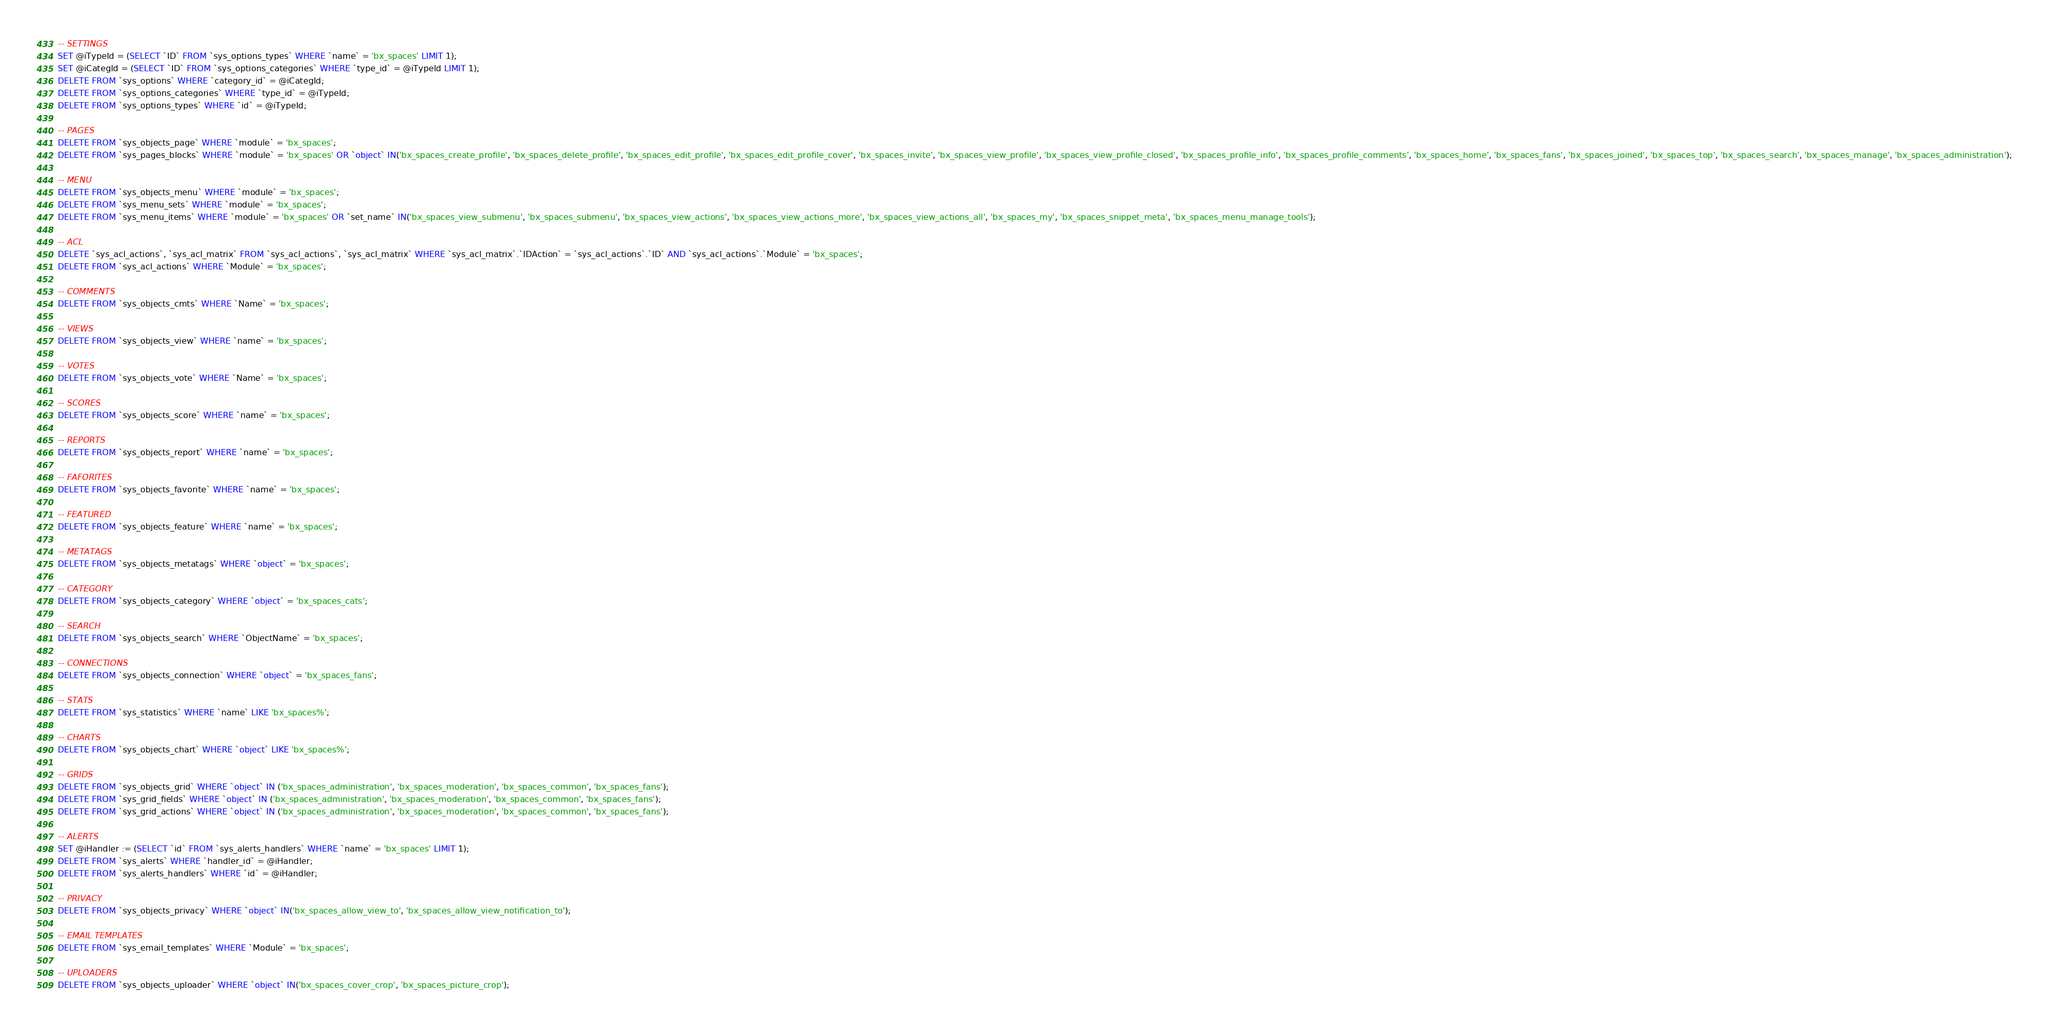<code> <loc_0><loc_0><loc_500><loc_500><_SQL_>
-- SETTINGS
SET @iTypeId = (SELECT `ID` FROM `sys_options_types` WHERE `name` = 'bx_spaces' LIMIT 1);
SET @iCategId = (SELECT `ID` FROM `sys_options_categories` WHERE `type_id` = @iTypeId LIMIT 1);
DELETE FROM `sys_options` WHERE `category_id` = @iCategId;
DELETE FROM `sys_options_categories` WHERE `type_id` = @iTypeId;
DELETE FROM `sys_options_types` WHERE `id` = @iTypeId;

-- PAGES
DELETE FROM `sys_objects_page` WHERE `module` = 'bx_spaces';
DELETE FROM `sys_pages_blocks` WHERE `module` = 'bx_spaces' OR `object` IN('bx_spaces_create_profile', 'bx_spaces_delete_profile', 'bx_spaces_edit_profile', 'bx_spaces_edit_profile_cover', 'bx_spaces_invite', 'bx_spaces_view_profile', 'bx_spaces_view_profile_closed', 'bx_spaces_profile_info', 'bx_spaces_profile_comments', 'bx_spaces_home', 'bx_spaces_fans', 'bx_spaces_joined', 'bx_spaces_top', 'bx_spaces_search', 'bx_spaces_manage', 'bx_spaces_administration');

-- MENU
DELETE FROM `sys_objects_menu` WHERE `module` = 'bx_spaces';
DELETE FROM `sys_menu_sets` WHERE `module` = 'bx_spaces';
DELETE FROM `sys_menu_items` WHERE `module` = 'bx_spaces' OR `set_name` IN('bx_spaces_view_submenu', 'bx_spaces_submenu', 'bx_spaces_view_actions', 'bx_spaces_view_actions_more', 'bx_spaces_view_actions_all', 'bx_spaces_my', 'bx_spaces_snippet_meta', 'bx_spaces_menu_manage_tools');

-- ACL
DELETE `sys_acl_actions`, `sys_acl_matrix` FROM `sys_acl_actions`, `sys_acl_matrix` WHERE `sys_acl_matrix`.`IDAction` = `sys_acl_actions`.`ID` AND `sys_acl_actions`.`Module` = 'bx_spaces';
DELETE FROM `sys_acl_actions` WHERE `Module` = 'bx_spaces';

-- COMMENTS
DELETE FROM `sys_objects_cmts` WHERE `Name` = 'bx_spaces';

-- VIEWS
DELETE FROM `sys_objects_view` WHERE `name` = 'bx_spaces';

-- VOTES
DELETE FROM `sys_objects_vote` WHERE `Name` = 'bx_spaces';

-- SCORES
DELETE FROM `sys_objects_score` WHERE `name` = 'bx_spaces';

-- REPORTS
DELETE FROM `sys_objects_report` WHERE `name` = 'bx_spaces';

-- FAFORITES
DELETE FROM `sys_objects_favorite` WHERE `name` = 'bx_spaces';

-- FEATURED
DELETE FROM `sys_objects_feature` WHERE `name` = 'bx_spaces';

-- METATAGS
DELETE FROM `sys_objects_metatags` WHERE `object` = 'bx_spaces';

-- CATEGORY
DELETE FROM `sys_objects_category` WHERE `object` = 'bx_spaces_cats';

-- SEARCH
DELETE FROM `sys_objects_search` WHERE `ObjectName` = 'bx_spaces';

-- CONNECTIONS
DELETE FROM `sys_objects_connection` WHERE `object` = 'bx_spaces_fans';

-- STATS
DELETE FROM `sys_statistics` WHERE `name` LIKE 'bx_spaces%';

-- CHARTS
DELETE FROM `sys_objects_chart` WHERE `object` LIKE 'bx_spaces%';

-- GRIDS
DELETE FROM `sys_objects_grid` WHERE `object` IN ('bx_spaces_administration', 'bx_spaces_moderation', 'bx_spaces_common', 'bx_spaces_fans');
DELETE FROM `sys_grid_fields` WHERE `object` IN ('bx_spaces_administration', 'bx_spaces_moderation', 'bx_spaces_common', 'bx_spaces_fans');
DELETE FROM `sys_grid_actions` WHERE `object` IN ('bx_spaces_administration', 'bx_spaces_moderation', 'bx_spaces_common', 'bx_spaces_fans');

-- ALERTS
SET @iHandler := (SELECT `id` FROM `sys_alerts_handlers` WHERE `name` = 'bx_spaces' LIMIT 1);
DELETE FROM `sys_alerts` WHERE `handler_id` = @iHandler;
DELETE FROM `sys_alerts_handlers` WHERE `id` = @iHandler;

-- PRIVACY 
DELETE FROM `sys_objects_privacy` WHERE `object` IN('bx_spaces_allow_view_to', 'bx_spaces_allow_view_notification_to');

-- EMAIL TEMPLATES
DELETE FROM `sys_email_templates` WHERE `Module` = 'bx_spaces';

-- UPLOADERS
DELETE FROM `sys_objects_uploader` WHERE `object` IN('bx_spaces_cover_crop', 'bx_spaces_picture_crop');
</code> 